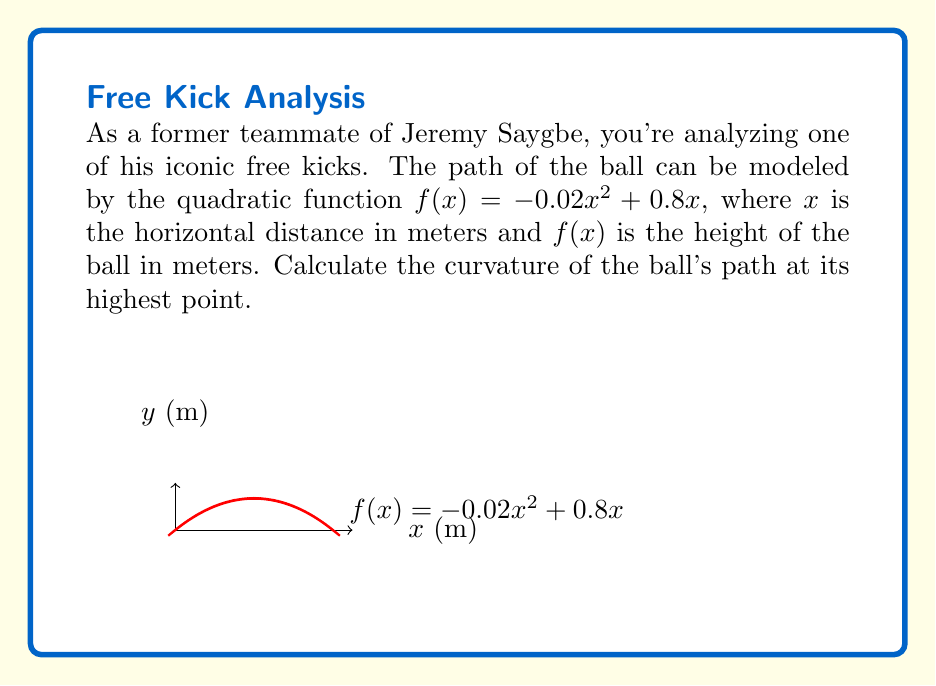Can you solve this math problem? To find the curvature at the highest point, we'll follow these steps:

1) First, find the x-coordinate of the highest point by setting $f'(x) = 0$:
   $$f'(x) = -0.04x + 0.8$$
   $$-0.04x + 0.8 = 0$$
   $$x = 20$$

2) The curvature $\kappa$ at any point is given by:
   $$\kappa = \frac{|f''(x)|}{(1 + (f'(x))^2)^{3/2}}$$

3) Calculate $f'(x)$ and $f''(x)$:
   $$f'(x) = -0.04x + 0.8$$
   $$f''(x) = -0.04$$

4) At $x = 20$ (the highest point):
   $$f'(20) = -0.04(20) + 0.8 = 0$$
   $$f''(20) = -0.04$$

5) Substitute into the curvature formula:
   $$\kappa = \frac{|-0.04|}{(1 + (0)^2)^{3/2}} = 0.04$$

Therefore, the curvature at the highest point of the free kick path is 0.04 m^(-1).
Answer: 0.04 m^(-1) 